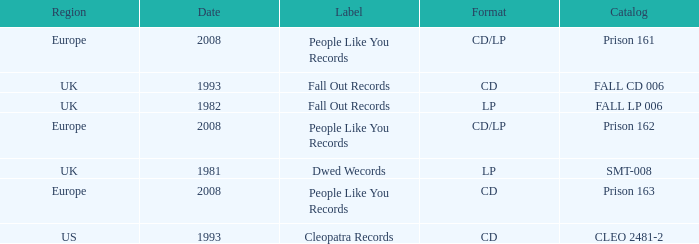Which Format has a Date of 1993, and a Catalog of cleo 2481-2? CD. 